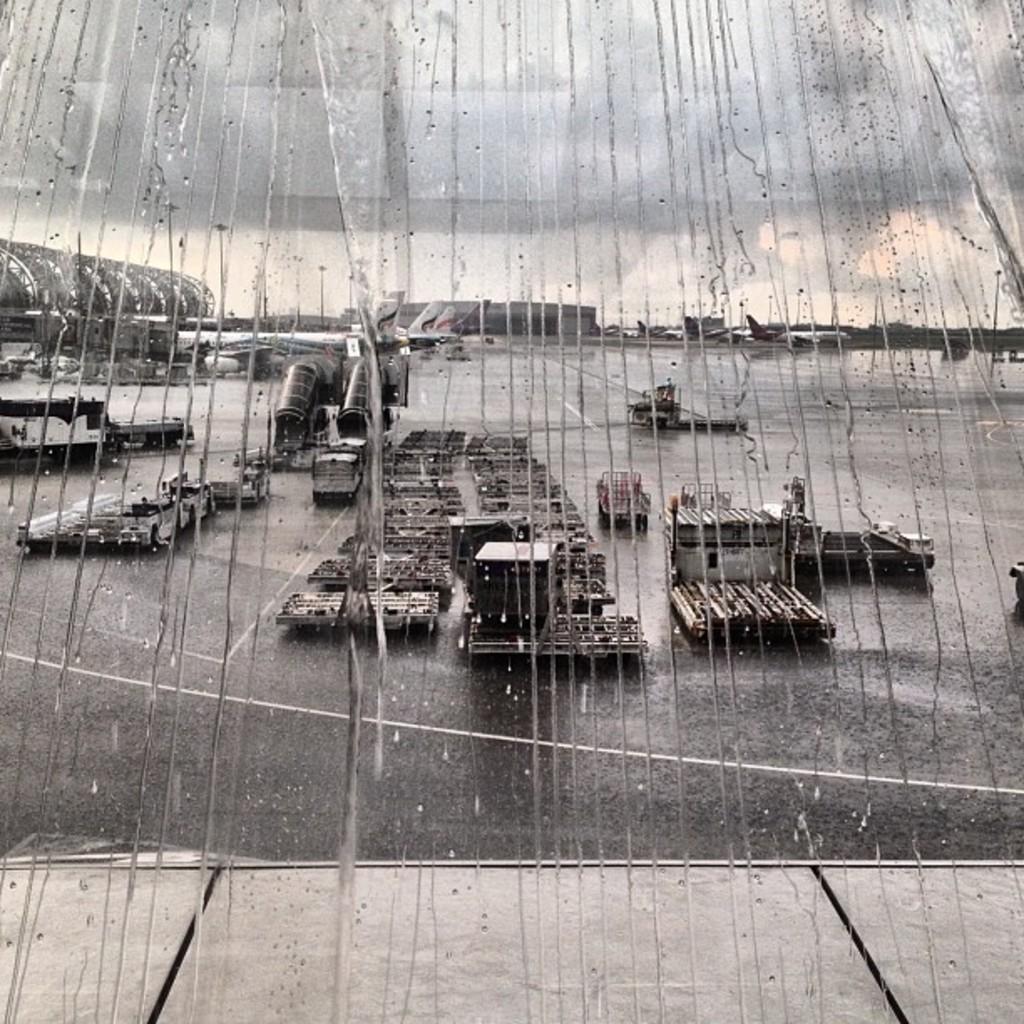Describe this image in one or two sentences. In this image I can see it is raining on the glass window. It looks like an airport. 